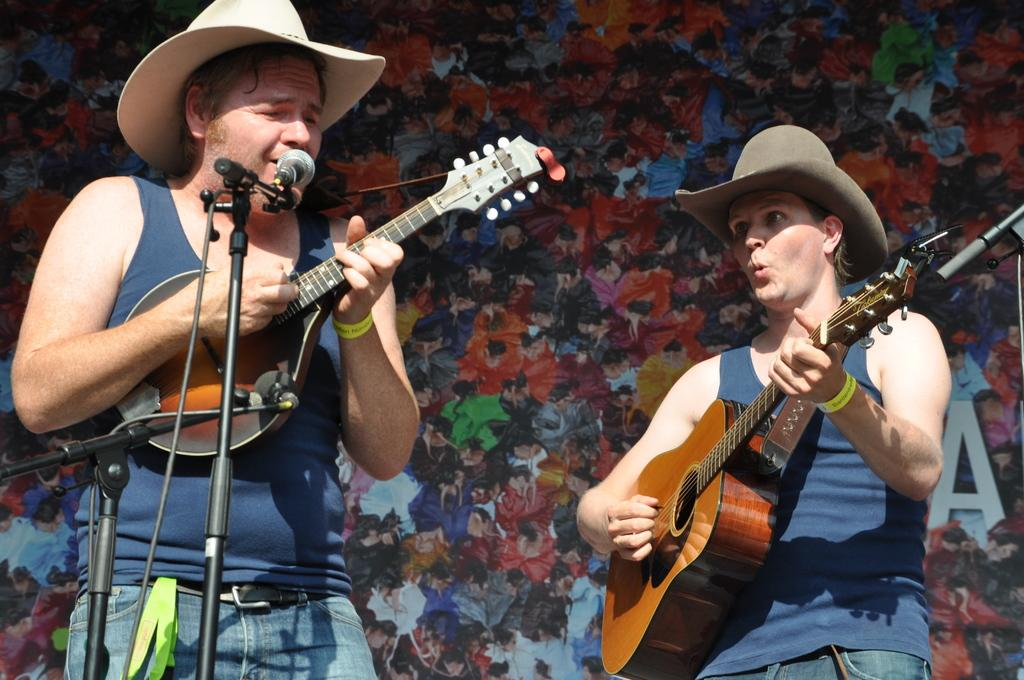How many people are in the image? There are two people in the image, a man and a woman. What are the man and the woman doing in the image? Both the man and the woman are holding musical instruments. What are the man and the woman wearing on their heads? The man and the woman are wearing hats. What is the man standing in front of in the image? The man is standing in front of a microphone. What type of payment is being made in the image? There is no indication of any payment being made in the image. --- Facts: 1. There is a car in the image. 2. The car is red. 3. The car has four doors. 4. The car has a sunroof. Absurd Topics: unicorn, rainbow, umbrella Conversation: versation: What is the main subject of the image? The main subject of the image is a car. What color is the car in the image? The car in the image is red. How many doors does the car have? The car has four doors. Does the car have any special features? Yes, the car has a sunroof. Reasoning: Let's think step by step in order to produce the conversation. We start by identifying the main subject of the image, which is the car. Then, we describe the color of the car, which is red. Next, we mention the number of doors the car has, which is four. Finally, we focus on a special feature of the car, which is the sunroof. Absurd Question/Answer: Can you see a unicorn jumping over a rainbow in the image? No, there is no unicorn or rainbow present in the image. --- Facts: 1. There is a group of people in the image. 2. The people are wearing matching outfits. 3. The outfits are blue and white. 4. The people are holding hands. 5. They are standing in a circle. Absurd Topics: parrot, bicycle, mountain Conversation: How many people are in the image? There is a group of people in the image. What are the people wearing in the image? The people are wearing matching outfits that are blue and white. What are the people doing in the image? The people are holding hands and standing in a circle. Reasoning: Let's think step by step in order to produce the conversation. We start by identifying the main subject of the image, which is the group of people. Then, we describe what the people are wearing, which are matching blue and white outfits. Next, we mention the action the people are performing, which is holding hands and standing in a circle. Absurd Question/Answer: 